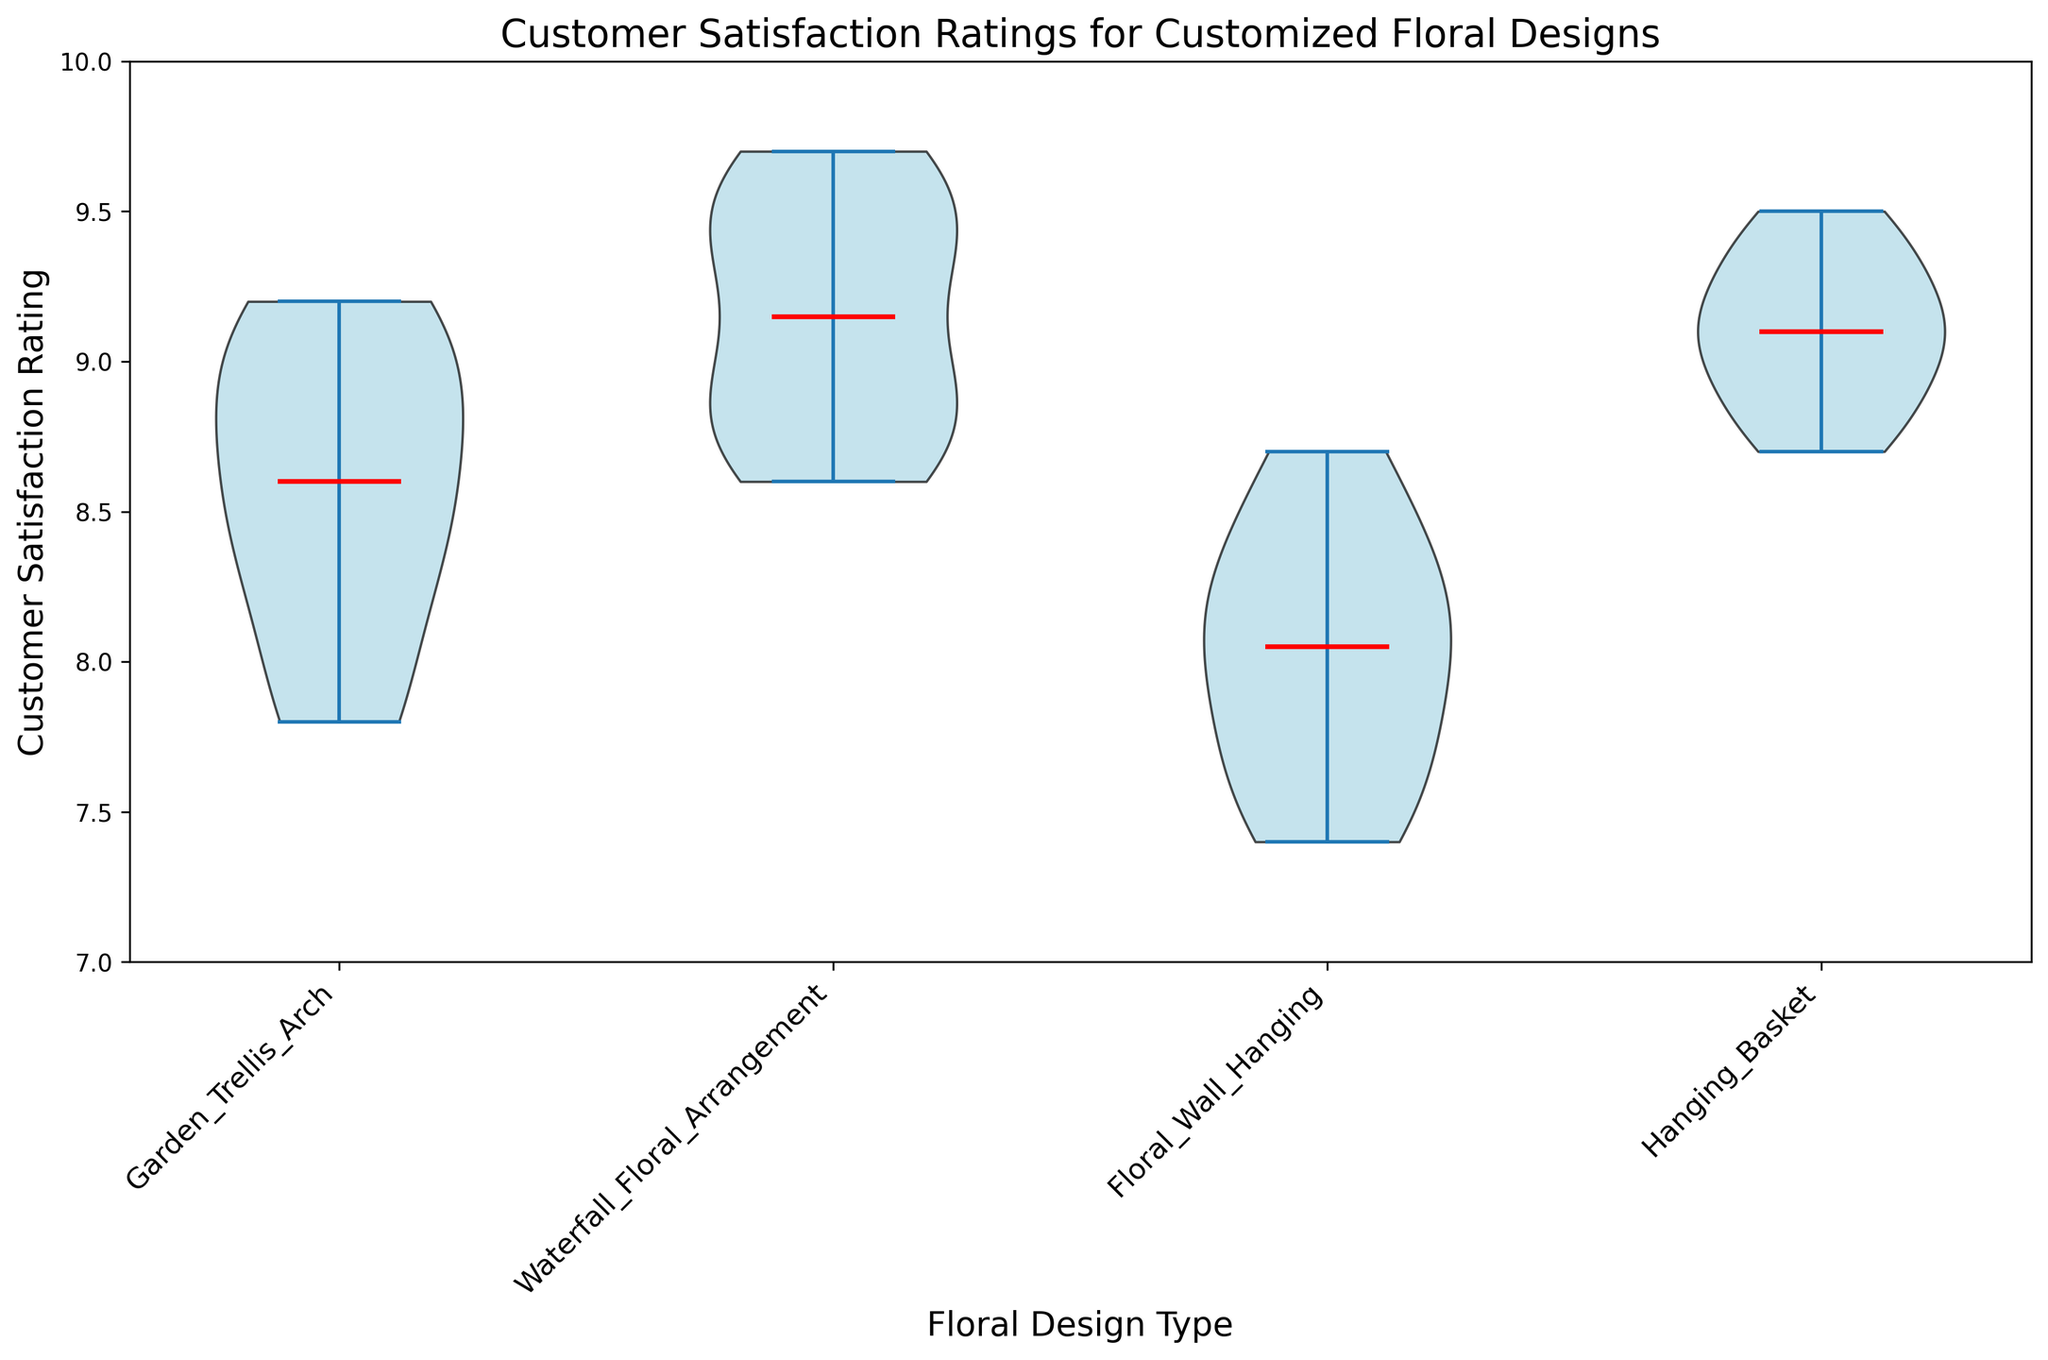How many different types of floral designs are compared in the plot? By looking at the x-axis labels, we can see that there are four unique floral design types mentioned.
Answer: Four Which floral design type has the highest median customer satisfaction rating? From the violin plot, the median is marked by a red line. The design type with the highest median, that is, the longest red line towards the higher end of the y-axis, is the "Waterfall Floral Arrangement."
Answer: Waterfall Floral Arrangement What is the range of customer satisfaction ratings for the "Floral Wall Hanging"? The range can be determined by looking at the extent of the violin plot for "Floral Wall Hanging." It stretches from approximately 7.4 to 8.7.
Answer: 7.4 to 8.7 Compare the spread of ratings between "Garden Trellis Arch" and "Hanging Basket." Which has a wider spread? The spread of ratings is shown by the vertical extent of the violin plots. "Garden Trellis Arch" ranges roughly from 7.8 to 9.2, while "Hanging Basket" ranges from about 8.7 to 9.5. The range for "Garden Trellis Arch" is wider.
Answer: Garden Trellis Arch Which design type shows the least variation in customer satisfaction ratings? Variation can be assessed by the width and height of the violin plots. The narrower and shorter the plot, the less variation. The "Hanging Basket" violin plot is relatively narrow and covers a smaller range, indicating less variation.
Answer: Hanging Basket For which design type does the median satisfaction rating exceed 9.0? By looking at the red median lines, we can see which ones are above 9.0. For "Waterfall Floral Arrangement," the median line is above 9.0.
Answer: Waterfall Floral Arrangement Are there any floral design types where all satisfaction ratings are below 9.0? Examining the y-axis limits of the violin plots, "Floral Wall Hanging" has no ratings reaching 9.0 or above.
Answer: Floral Wall Hanging What is the median customer satisfaction rating for the "Garden Trellis Arch"? The median is indicated by the red line within the "Garden Trellis Arch" violin plot. This line is around 8.5.
Answer: 8.5 